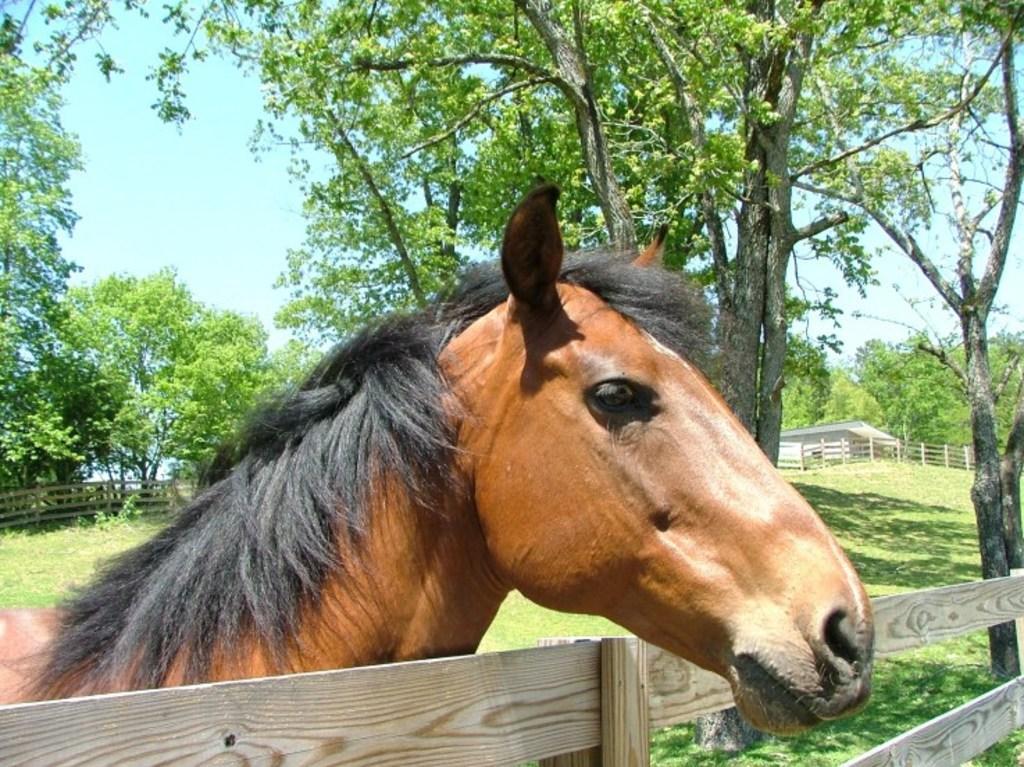How would you summarize this image in a sentence or two? This image consists of a horse in brown color. At the bottom, there is a fencing made up of wood. And there is green grass on the ground. In the background, there are trees. On the right, we can see a small house. At the top, there is sky. 